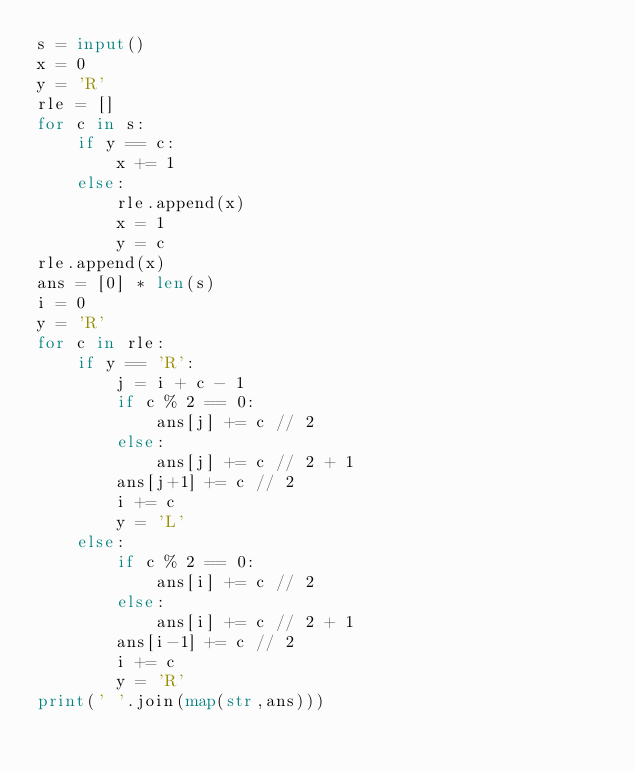<code> <loc_0><loc_0><loc_500><loc_500><_Python_>s = input()
x = 0
y = 'R'
rle = []
for c in s:
    if y == c:
        x += 1
    else:
        rle.append(x)
        x = 1
        y = c
rle.append(x)
ans = [0] * len(s)
i = 0
y = 'R'
for c in rle:
    if y == 'R':
        j = i + c - 1
        if c % 2 == 0:
            ans[j] += c // 2
        else:
            ans[j] += c // 2 + 1
        ans[j+1] += c // 2
        i += c
        y = 'L'
    else:
        if c % 2 == 0:
            ans[i] += c // 2
        else:
            ans[i] += c // 2 + 1
        ans[i-1] += c // 2
        i += c
        y = 'R'
print(' '.join(map(str,ans)))</code> 